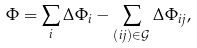<formula> <loc_0><loc_0><loc_500><loc_500>\Phi = \sum _ { i } \Delta \Phi _ { i } - \sum _ { ( i j ) \in \mathcal { G } } \Delta \Phi _ { i j } ,</formula> 